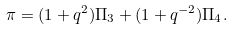<formula> <loc_0><loc_0><loc_500><loc_500>\pi = ( 1 + q ^ { 2 } ) \Pi _ { 3 } + ( 1 + q ^ { - 2 } ) \Pi _ { 4 } .</formula> 